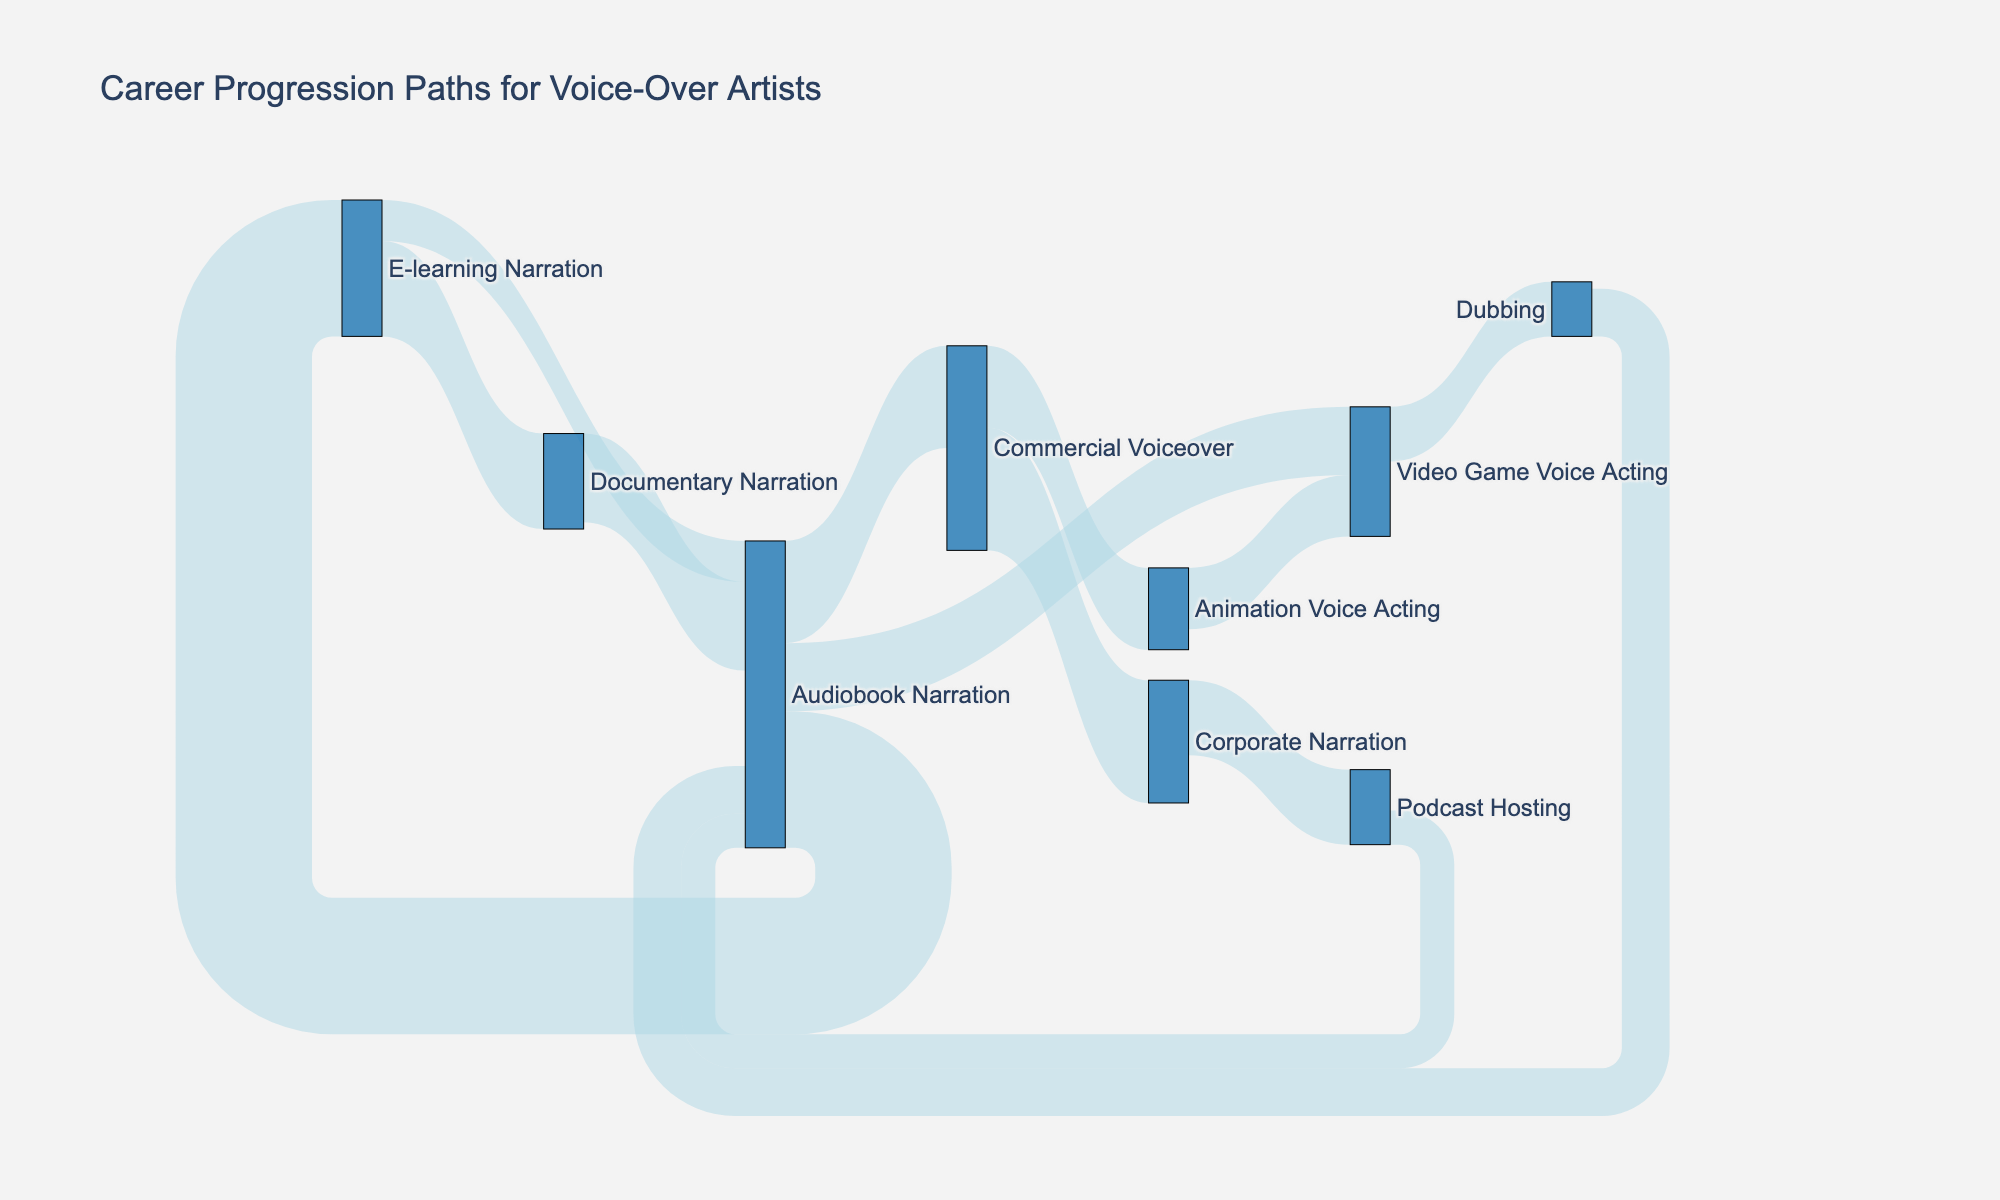What's the highest transition count from Audiobook Narration to another field? By inspecting the diagram, we see the transitions from Audiobook Narration and compare their values: 15 to Commercial Voiceover, 10 to Video Game Voice Acting, and 20 to E-learning Narration. The highest is 20 to E-learning Narration.
Answer: 20 Which field has the most connections leading into Audiobook Narration? The sources linked to Audiobook Narration are E-learning Narration (6), Dubbing (7), Documentary Narration (13), and Podcast Hosting (5). Adding these values Total = 6 + 7 + 13 + 5 = 31.
Answer: E-learning Narration, Dubbing, Documentary Narration, Podcast Hosting What is the total number of transitions leading out from Commercial Voiceover? Sum the values of all transitions leading out from Commercial Voiceover: 12 to Animation Voice Acting and 18 to Corporate Narration. So, 12 + 18 = 30.
Answer: 30 Which field has the least transitions coming into Audiobook Narration? Compare the values of all transitions leading to Audiobook Narration: 6 from E-learning Narration, 7 from Dubbing, 13 from Documentary Narration, and 5 from Podcast Hosting. The smallest value is 5, from Podcast Hosting.
Answer: Podcast Hosting How many transitions end at Video Game Voice Acting? Look at the in-flow for Video Game Voice Acting: 10 from Audiobook Narration and 9 from Animation Voice Acting. Add these up, 10 + 9 = 19.
Answer: 19 Compare transitions from Video Game Voice Acting to Dubbing and Audiobook Narration to Commercial Voiceover. Which has more? The transition from Video Game Voice Acting to Dubbing is 8, and from Audiobook Narration to Commercial Voiceover is 15. The transition from Audiobook Narration to Commercial Voiceover is higher.
Answer: Audiobook Narration to Commercial Voiceover Which field has the highest number of transitions leading out? Tally the out-flow values for each source: Audiobook Narration (15 + 10 + 20 = 45), Commercial Voiceover (12 + 18 = 30), Video Game Voice Acting (8), E-learning Narration (14 + 6 = 20), Animation Voice Acting (9), Corporate Narration (11), Dubbing (7), Documentary Narration (13), Podcast Hosting (5). Audiobook Narration has the highest total with 45.
Answer: Audiobook Narration What fraction of transitions from Audiobook Narration to E-learning Narration are of total transitions out of Audiobook Narration? Calculate the total out-flow from Audiobook Narration: 15 (Commercial Voiceover) + 10 (Video Game Voice Acting) + 20 (E-learning Narration) = 45. The fraction for E-learning Narration is 20/45. Simplify to approximately 4/9.
Answer: 4/9 